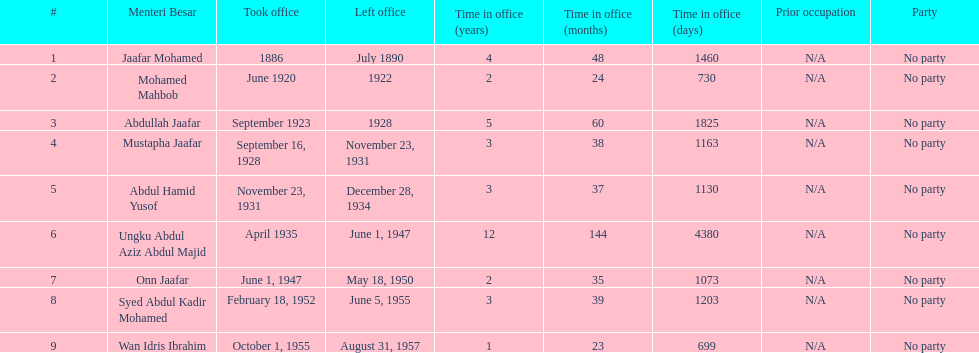How long did ungku abdul aziz abdul majid serve? 12 years. 